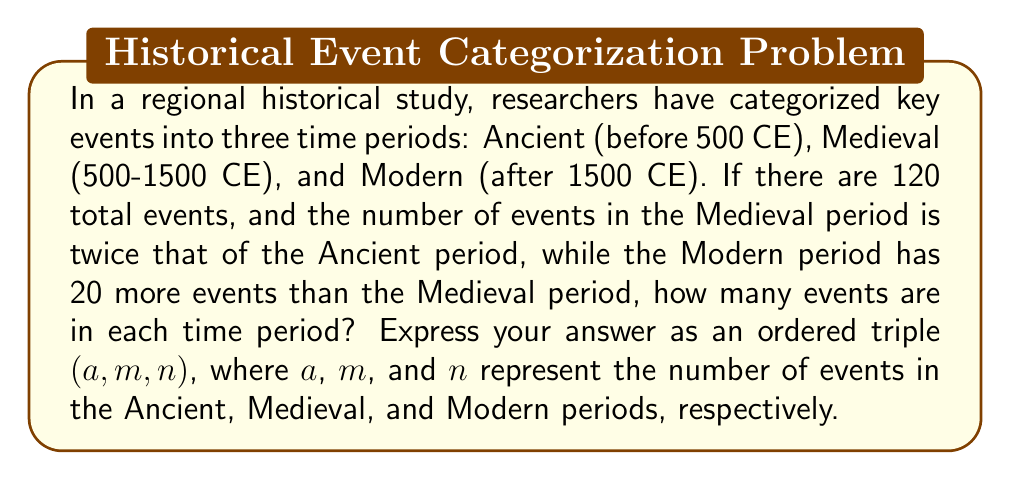Help me with this question. Let's approach this step-by-step:

1) Let $a$ be the number of events in the Ancient period.

2) Given that the Medieval period has twice as many events as the Ancient period, we can express it as $2a$.

3) The Modern period has 20 more events than the Medieval period, so we can express it as $2a + 20$.

4) We know that the total number of events is 120. We can set up an equation:

   $a + 2a + (2a + 20) = 120$

5) Simplify the left side of the equation:

   $5a + 20 = 120$

6) Subtract 20 from both sides:

   $5a = 100$

7) Divide both sides by 5:

   $a = 20$

8) Now that we know $a$, we can calculate the other values:
   - Ancient (a): 20
   - Medieval (2a): $2 * 20 = 40$
   - Modern (2a + 20): $2 * 20 + 20 = 60$

9) Therefore, the distribution is (20, 40, 60).
Answer: (20, 40, 60) 